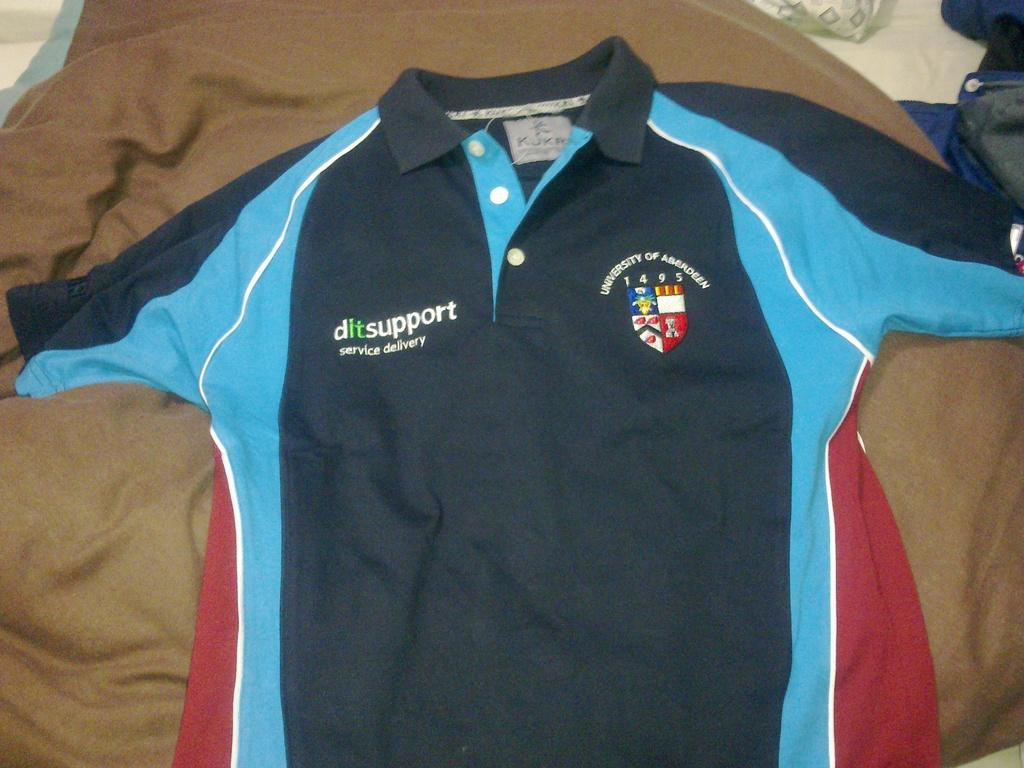<image>
Summarize the visual content of the image. A black blue and red polo shirt from the University of Aberdeen. 